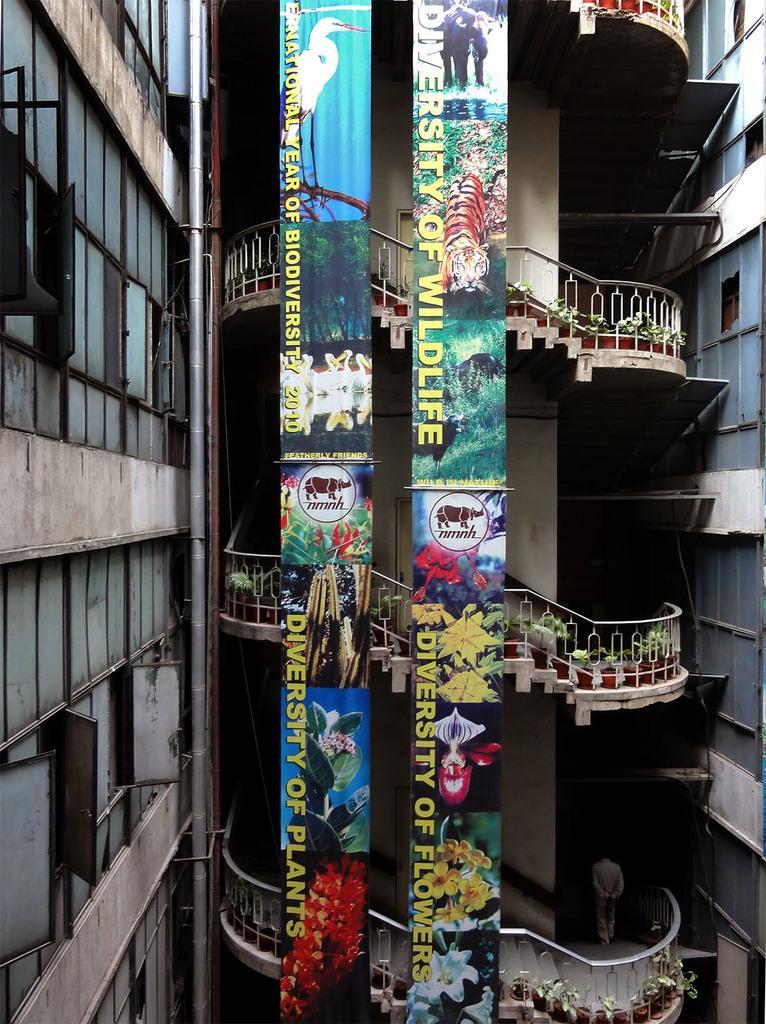Could you give a brief overview of what you see in this image? In this image, we can see stairs, railings, plants with pots, walls and doors. Here we can see banners. On the right side and left side, we can see buildings. At the bottom of the image, we can see a person. On the left side, we can see windows. 